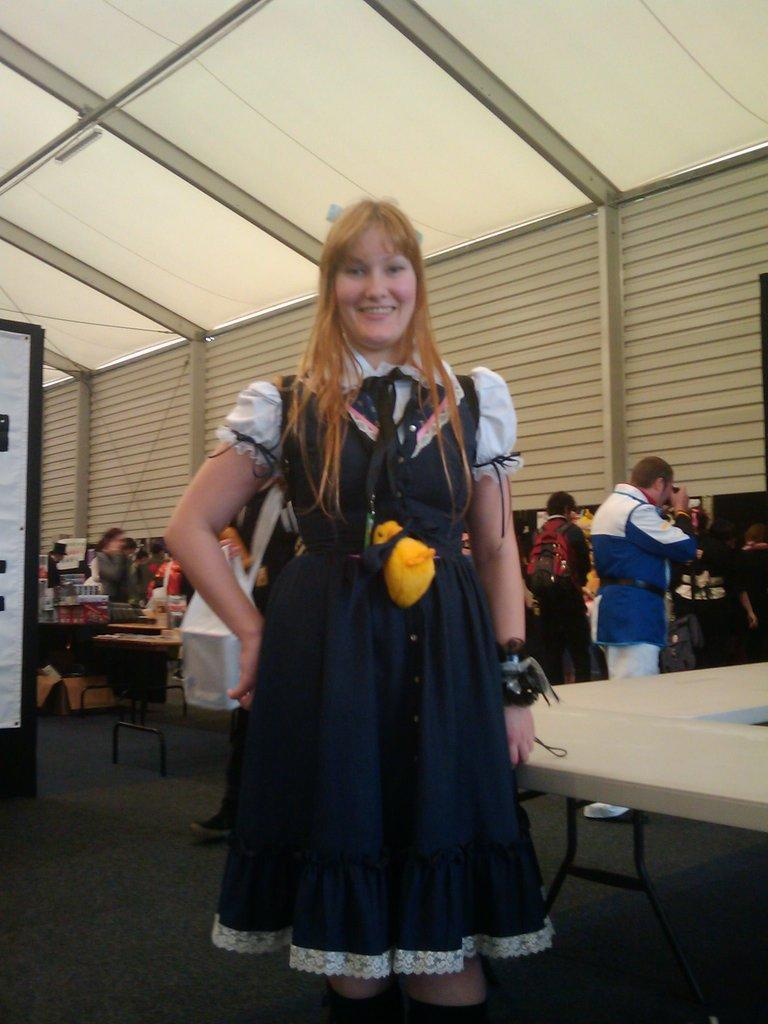In one or two sentences, can you explain what this image depicts? In this image we can see a woman standing and smiling, and at back here is the table, and at side here are the people standing, and here is the wall, and at above here is the roof. 